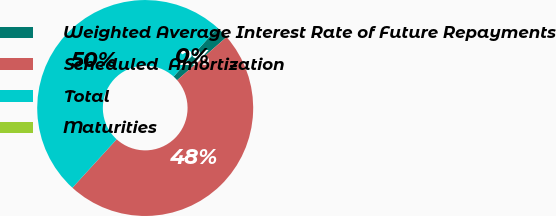Convert chart. <chart><loc_0><loc_0><loc_500><loc_500><pie_chart><fcel>Weighted Average Interest Rate of Future Repayments<fcel>Scheduled  Amortization<fcel>Total<fcel>Maturities<nl><fcel>1.91%<fcel>48.18%<fcel>49.9%<fcel>0.0%<nl></chart> 